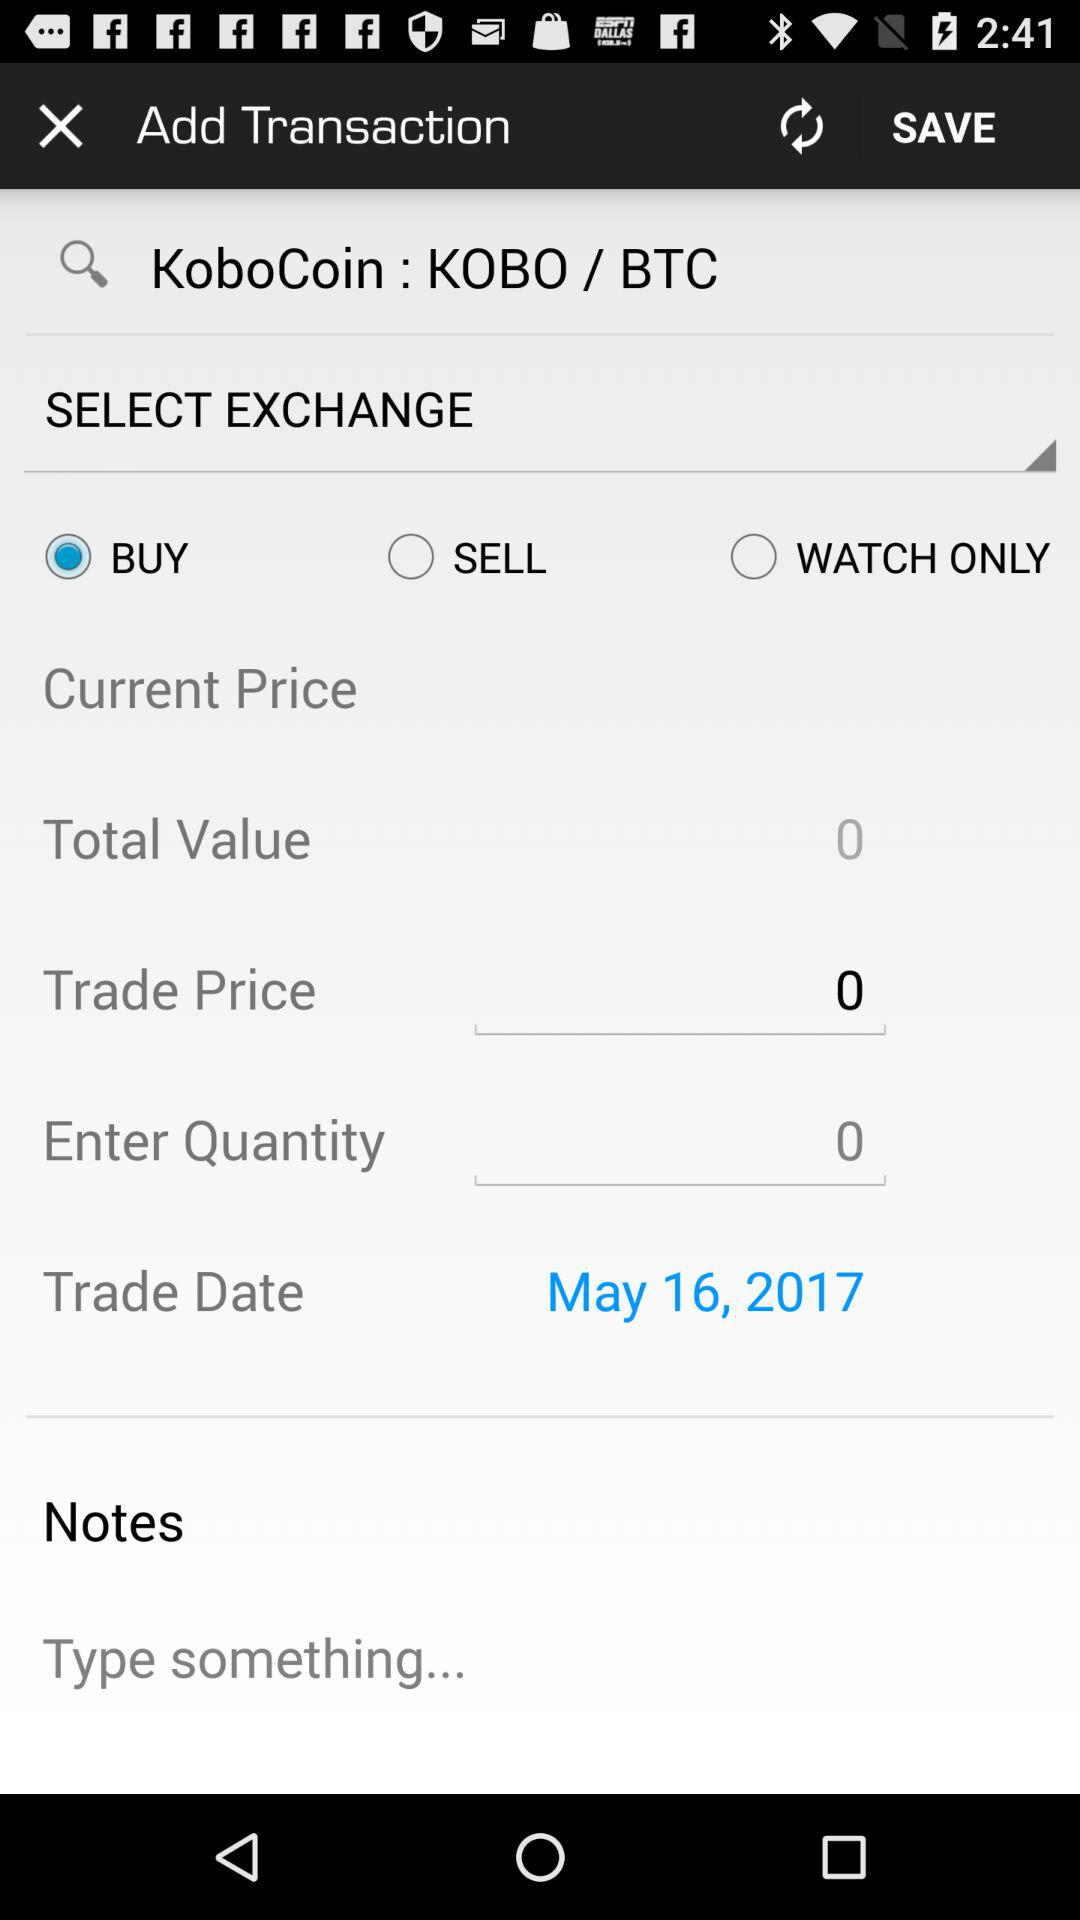What is the total value? The total value is 0. 